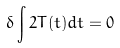Convert formula to latex. <formula><loc_0><loc_0><loc_500><loc_500>\delta \int 2 T ( t ) d t = 0</formula> 